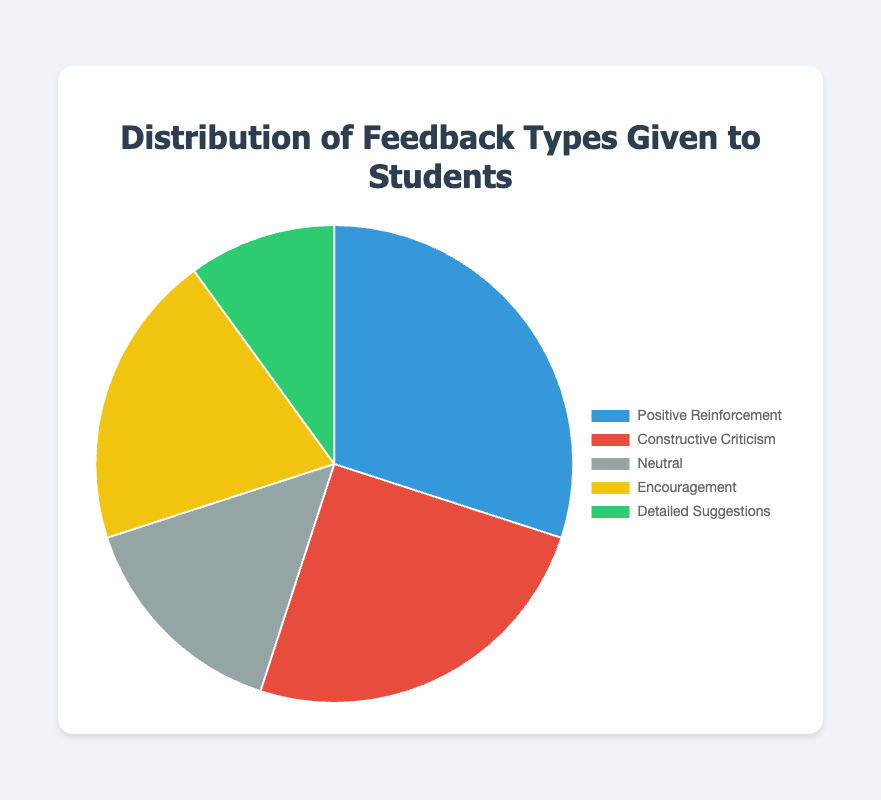What percentage of feedback is either Positive Reinforcement or Encouragement? Add the percentages for Positive Reinforcement (30%) and Encouragement (20%). 30 + 20 = 50
Answer: 50% Which feedback type has the smallest percentage? Compare the percentages of all feedback types. Detailed Suggestions has the smallest with 10%
Answer: Detailed Suggestions Is the percentage of Constructive Criticism greater than the sum of Neutral and Detailed Suggestions? Add the percentages of Neutral (15%) and Detailed Suggestions (10%), and compare to Constructive Criticism (25%). 15 + 10 = 25, which is equal to Constructive Criticism
Answer: No What is the difference in percentage between Positive Reinforcement and Constructive Criticism? Subtract the percentage of Constructive Criticism (25%) from Positive Reinforcement (30%). 30 - 25 = 5
Answer: 5% How many feedback types have a percentage greater than 15%? Identify and count the feedback types exceeding 15%: Positive Reinforcement (30%), Constructive Criticism (25%), and Encouragement (20%). There are three
Answer: 3 Which feedback type is represented by the yellow segment in the pie chart? The color code for segments indicates Encouragement is yellow
Answer: Encouragement If you combine Neutral and Detailed Suggestions, will their total percentage exceed Encouragement's percentage? Add Neutral (15%) and Detailed Suggestions (10%). 15 + 10 = 25, compare this to Encouragement (20%). 25 > 20
Answer: Yes What is the average percentage of Positive Reinforcement, Constructive Criticism, and Encouragement? Add the percentages and divide by 3. (30 + 25 + 20)/3 = 25
Answer: 25 Rank the feedback types from highest to lowest percentage. Compare all percentages: Positive Reinforcement (30%), Constructive Criticism (25%), Encouragement (20%), Neutral (15%), Detailed Suggestions (10%)
Answer: Positive Reinforcement, Constructive Criticism, Encouragement, Neutral, Detailed Suggestions 